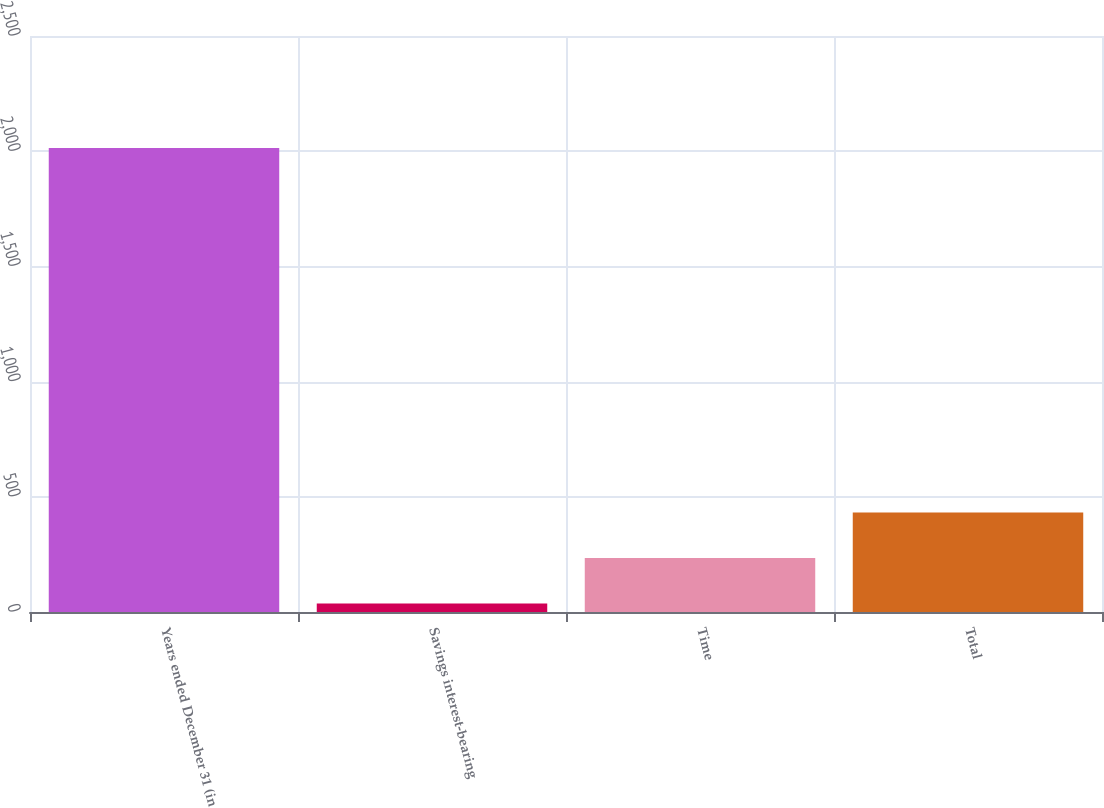Convert chart. <chart><loc_0><loc_0><loc_500><loc_500><bar_chart><fcel>Years ended December 31 (in<fcel>Savings interest-bearing<fcel>Time<fcel>Total<nl><fcel>2014<fcel>36.7<fcel>234.43<fcel>432.16<nl></chart> 